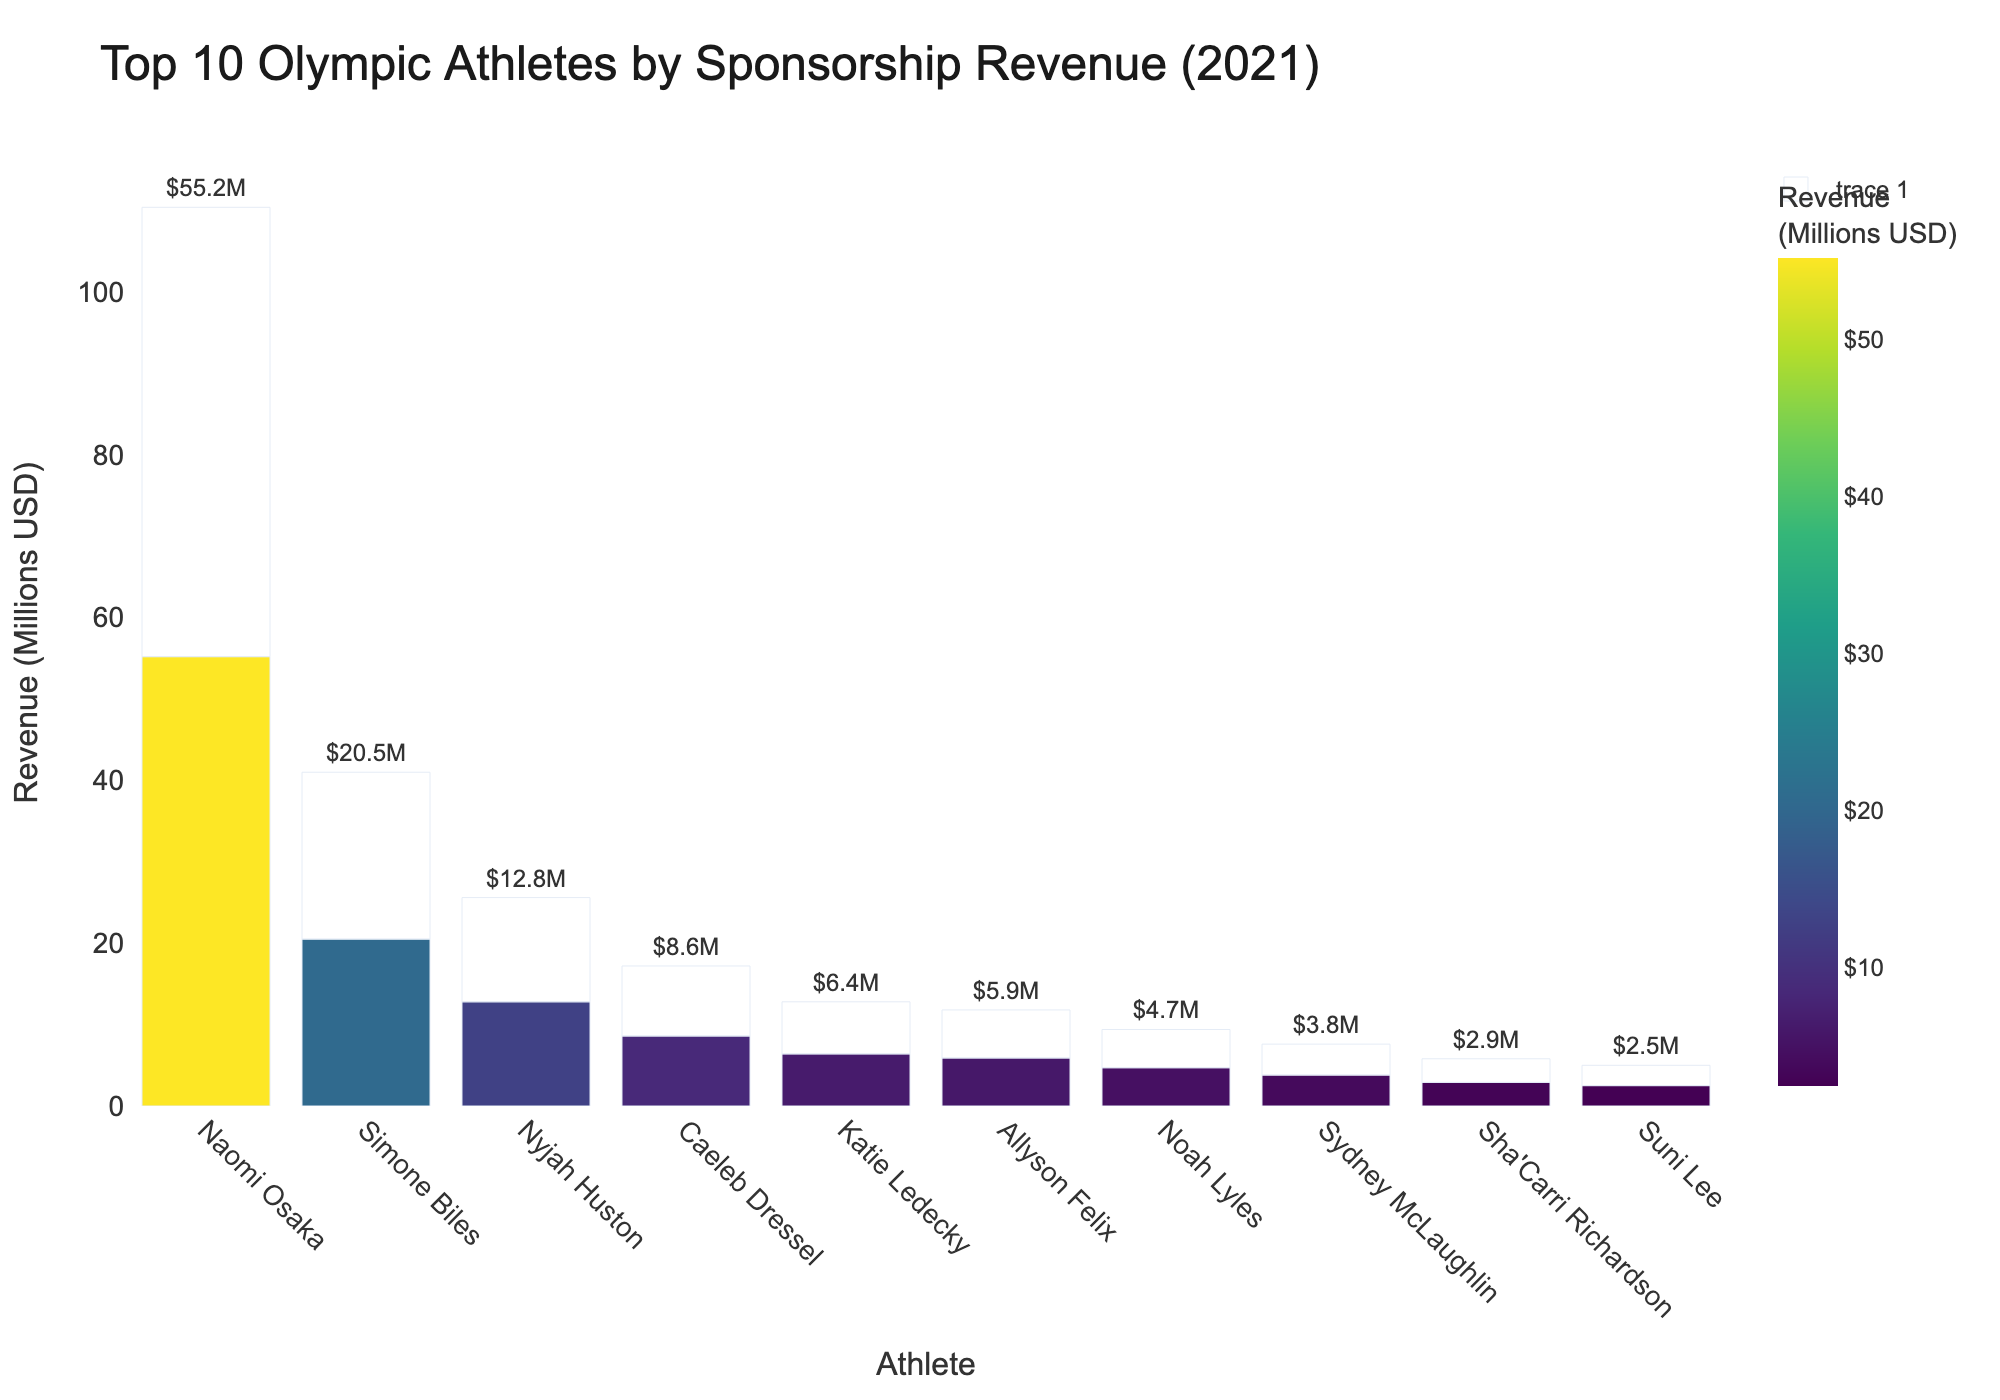What's the highest sponsorship revenue represented in the chart, and which athlete does it belong to? The highest bar in the chart represents the highest sponsorship revenue, which belongs to Naomi Osaka at $55.2 million.
Answer: Naomi Osaka; $55.2 million Which athlete has the lowest sponsorship revenue, and how much is it? The shortest bar in the chart corresponds to the athlete with the lowest sponsorship revenue, which is Suni Lee at $2.5 million.
Answer: Suni Lee; $2.5 million What is the total sponsorship revenue for the top 3 athletes combined? Add the sponsorship revenues of the top 3 athletes: Naomi Osaka ($55.2M), Simone Biles ($20.5M), and Nyjah Huston ($12.8M). $55.2M + $20.5M + $12.8M = $88.5M.
Answer: $88.5 million How much more sponsorship revenue does Naomi Osaka have compared to Simone Biles? Subtract Simone Biles' revenue from Naomi Osaka's revenue: $55.2M - $20.5M = $34.7M.
Answer: $34.7 million Which athlete has a higher sponsorship revenue, Allyson Felix or Katie Ledecky, and by how much? Compare the revenues of Allyson Felix and Katie Ledecky: $6.4M for Katie Ledecky and $5.9M for Allyson Felix. $6.4M - $5.9M = $0.5M. Katie Ledecky has a higher revenue by $0.5M.
Answer: Katie Ledecky; $0.5 million What is the average sponsorship revenue of the athletes listed in the chart? Sum all the sponsorship revenues and divide by the number of athletes. Total revenue = $55.2M + $20.5M + $12.8M + $8.6M + $6.4M + $5.9M + $4.7M + $3.8M + $2.9M + $2.5M = $123.3M. Average = $123.3M / 10 = $12.33M.
Answer: $12.33 million Which athlete is ranked 5th in terms of sponsorship revenue, and what is their revenue? The 5th highest bar in the chart represents Katie Ledecky with a sponsorship revenue of $6.4 million.
Answer: Katie Ledecky; $6.4 million Name two athletes whose combined sponsorship revenue is close to the sum of the sponsorship revenues of Simone Biles and Nyjah Huston? Simone Biles ($20.5M) and Nyjah Huston ($12.8M) together total $33.3M. A close combined total is Naomi Osaka ($55.2M) and Sydney McLaughlin ($3.8M), which equals $32.7M.
Answer: Naomi Osaka and Sydney McLaughlin What is the difference in sponsorship revenue between the highest and the lowest-ranked athletes in the chart? Subtract the lowest sponsorship revenue from the highest: $55.2M (Naomi Osaka) - $2.5M (Suni Lee) = $52.7M.
Answer: $52.7 million 